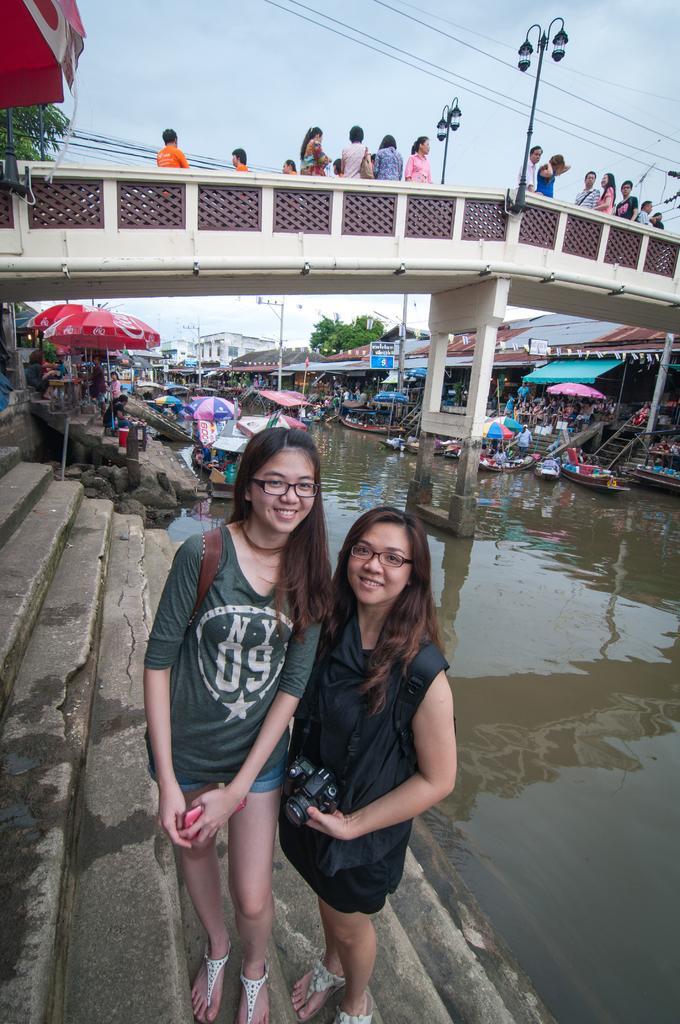In one or two sentences, can you explain what this image depicts? In this picture we can see two women wore spectacles and standing on the steps and smiling, umbrellas, boats on water, bridge, buildings, some persons and in the background we can see the sky. 